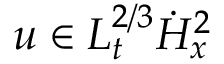<formula> <loc_0><loc_0><loc_500><loc_500>u \in L _ { t } ^ { 2 / 3 } \dot { H } _ { x } ^ { 2 }</formula> 